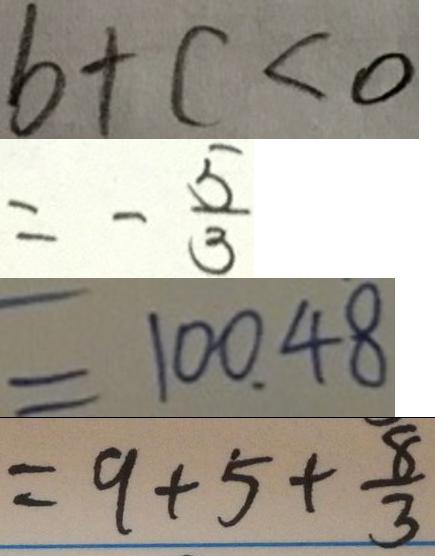<formula> <loc_0><loc_0><loc_500><loc_500>b + c < 0 
 = - \frac { 5 } { 3 } 
 = 1 0 0 . 4 8 
 = 9 + 5 + \frac { 8 } { 3 }</formula> 